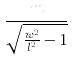Convert formula to latex. <formula><loc_0><loc_0><loc_500><loc_500>\frac { m } { \sqrt { \frac { w ^ { 2 } } { l ^ { 2 } } - 1 } }</formula> 